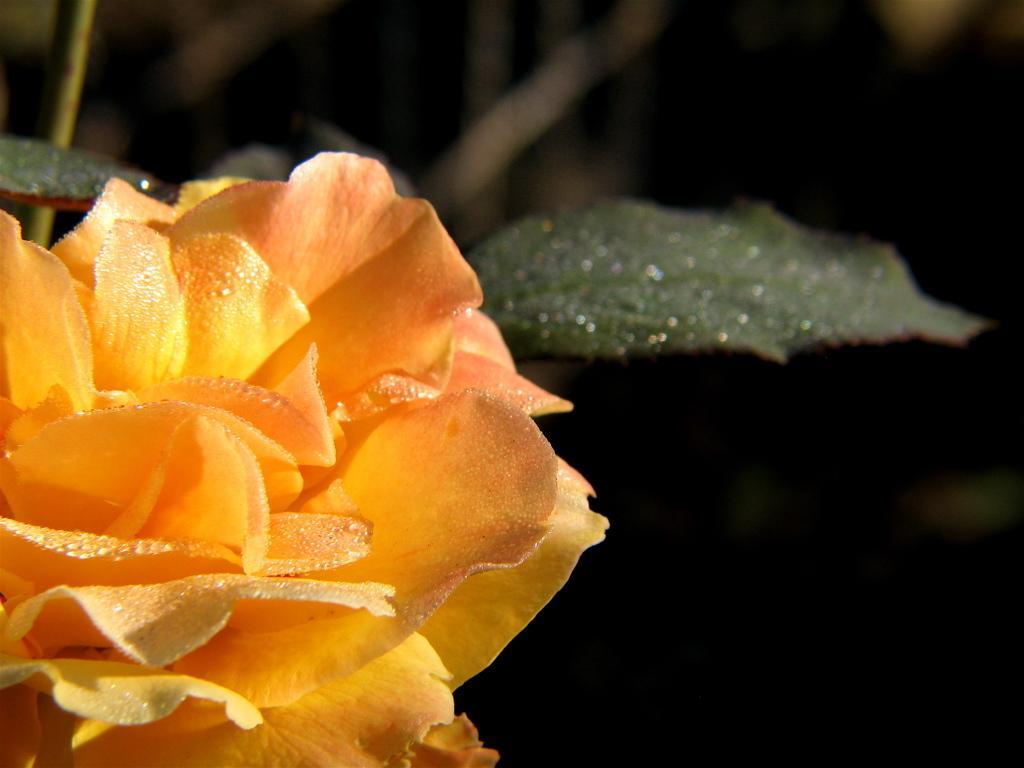Can you describe this image briefly? In this image on the left side there is one flower and leaves, and there is a dark background. 